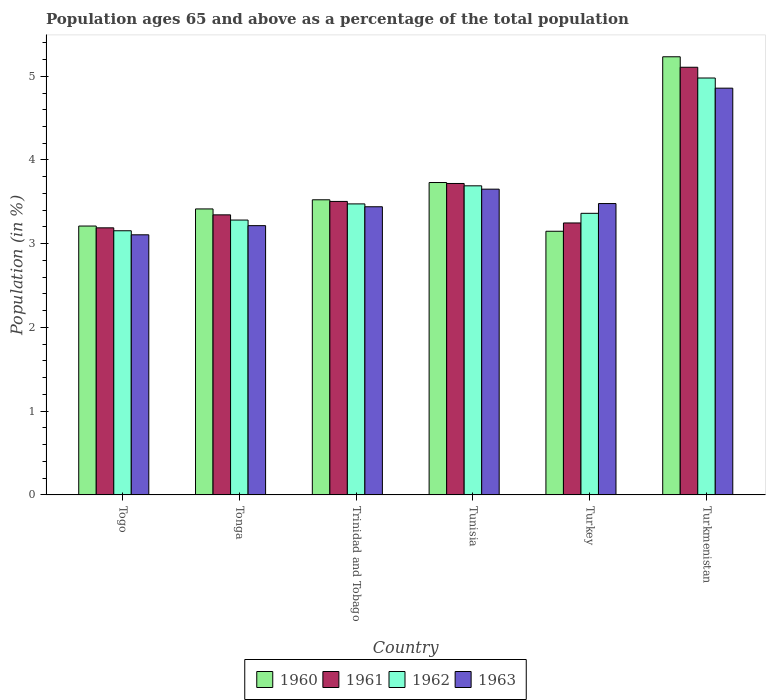How many groups of bars are there?
Your answer should be very brief. 6. Are the number of bars on each tick of the X-axis equal?
Your answer should be very brief. Yes. How many bars are there on the 6th tick from the left?
Your answer should be compact. 4. How many bars are there on the 2nd tick from the right?
Keep it short and to the point. 4. What is the label of the 3rd group of bars from the left?
Provide a succinct answer. Trinidad and Tobago. What is the percentage of the population ages 65 and above in 1963 in Turkmenistan?
Ensure brevity in your answer.  4.86. Across all countries, what is the maximum percentage of the population ages 65 and above in 1961?
Ensure brevity in your answer.  5.11. Across all countries, what is the minimum percentage of the population ages 65 and above in 1960?
Ensure brevity in your answer.  3.15. In which country was the percentage of the population ages 65 and above in 1963 maximum?
Give a very brief answer. Turkmenistan. In which country was the percentage of the population ages 65 and above in 1962 minimum?
Provide a succinct answer. Togo. What is the total percentage of the population ages 65 and above in 1962 in the graph?
Provide a succinct answer. 21.95. What is the difference between the percentage of the population ages 65 and above in 1962 in Tonga and that in Turkmenistan?
Your answer should be very brief. -1.7. What is the difference between the percentage of the population ages 65 and above in 1961 in Turkey and the percentage of the population ages 65 and above in 1960 in Tunisia?
Your answer should be compact. -0.48. What is the average percentage of the population ages 65 and above in 1962 per country?
Offer a very short reply. 3.66. What is the difference between the percentage of the population ages 65 and above of/in 1960 and percentage of the population ages 65 and above of/in 1963 in Turkmenistan?
Offer a terse response. 0.37. In how many countries, is the percentage of the population ages 65 and above in 1961 greater than 2.6?
Your answer should be very brief. 6. What is the ratio of the percentage of the population ages 65 and above in 1962 in Trinidad and Tobago to that in Turkey?
Keep it short and to the point. 1.03. Is the percentage of the population ages 65 and above in 1963 in Tunisia less than that in Turkmenistan?
Give a very brief answer. Yes. Is the difference between the percentage of the population ages 65 and above in 1960 in Togo and Tonga greater than the difference between the percentage of the population ages 65 and above in 1963 in Togo and Tonga?
Your response must be concise. No. What is the difference between the highest and the second highest percentage of the population ages 65 and above in 1960?
Your answer should be very brief. -0.21. What is the difference between the highest and the lowest percentage of the population ages 65 and above in 1960?
Your answer should be compact. 2.08. Is the sum of the percentage of the population ages 65 and above in 1963 in Tunisia and Turkmenistan greater than the maximum percentage of the population ages 65 and above in 1962 across all countries?
Provide a succinct answer. Yes. Is it the case that in every country, the sum of the percentage of the population ages 65 and above in 1963 and percentage of the population ages 65 and above in 1961 is greater than the percentage of the population ages 65 and above in 1962?
Give a very brief answer. Yes. What is the difference between two consecutive major ticks on the Y-axis?
Your answer should be very brief. 1. Are the values on the major ticks of Y-axis written in scientific E-notation?
Ensure brevity in your answer.  No. Where does the legend appear in the graph?
Make the answer very short. Bottom center. How many legend labels are there?
Offer a terse response. 4. What is the title of the graph?
Make the answer very short. Population ages 65 and above as a percentage of the total population. What is the label or title of the Y-axis?
Your response must be concise. Population (in %). What is the Population (in %) of 1960 in Togo?
Make the answer very short. 3.21. What is the Population (in %) of 1961 in Togo?
Provide a succinct answer. 3.19. What is the Population (in %) in 1962 in Togo?
Your answer should be very brief. 3.15. What is the Population (in %) of 1963 in Togo?
Make the answer very short. 3.11. What is the Population (in %) of 1960 in Tonga?
Your answer should be compact. 3.42. What is the Population (in %) in 1961 in Tonga?
Offer a very short reply. 3.34. What is the Population (in %) of 1962 in Tonga?
Ensure brevity in your answer.  3.28. What is the Population (in %) in 1963 in Tonga?
Offer a terse response. 3.22. What is the Population (in %) of 1960 in Trinidad and Tobago?
Your response must be concise. 3.52. What is the Population (in %) of 1961 in Trinidad and Tobago?
Your response must be concise. 3.51. What is the Population (in %) of 1962 in Trinidad and Tobago?
Provide a succinct answer. 3.48. What is the Population (in %) of 1963 in Trinidad and Tobago?
Your answer should be very brief. 3.44. What is the Population (in %) of 1960 in Tunisia?
Your answer should be compact. 3.73. What is the Population (in %) of 1961 in Tunisia?
Your response must be concise. 3.72. What is the Population (in %) of 1962 in Tunisia?
Provide a succinct answer. 3.69. What is the Population (in %) of 1963 in Tunisia?
Provide a short and direct response. 3.65. What is the Population (in %) in 1960 in Turkey?
Offer a terse response. 3.15. What is the Population (in %) of 1961 in Turkey?
Ensure brevity in your answer.  3.25. What is the Population (in %) in 1962 in Turkey?
Provide a succinct answer. 3.36. What is the Population (in %) of 1963 in Turkey?
Provide a succinct answer. 3.48. What is the Population (in %) of 1960 in Turkmenistan?
Offer a terse response. 5.23. What is the Population (in %) in 1961 in Turkmenistan?
Give a very brief answer. 5.11. What is the Population (in %) in 1962 in Turkmenistan?
Your answer should be very brief. 4.98. What is the Population (in %) of 1963 in Turkmenistan?
Provide a short and direct response. 4.86. Across all countries, what is the maximum Population (in %) in 1960?
Give a very brief answer. 5.23. Across all countries, what is the maximum Population (in %) of 1961?
Provide a succinct answer. 5.11. Across all countries, what is the maximum Population (in %) of 1962?
Provide a succinct answer. 4.98. Across all countries, what is the maximum Population (in %) in 1963?
Your response must be concise. 4.86. Across all countries, what is the minimum Population (in %) in 1960?
Your answer should be very brief. 3.15. Across all countries, what is the minimum Population (in %) in 1961?
Your answer should be very brief. 3.19. Across all countries, what is the minimum Population (in %) in 1962?
Offer a very short reply. 3.15. Across all countries, what is the minimum Population (in %) of 1963?
Offer a terse response. 3.11. What is the total Population (in %) of 1960 in the graph?
Keep it short and to the point. 22.26. What is the total Population (in %) in 1961 in the graph?
Provide a succinct answer. 22.11. What is the total Population (in %) of 1962 in the graph?
Your response must be concise. 21.95. What is the total Population (in %) of 1963 in the graph?
Keep it short and to the point. 21.75. What is the difference between the Population (in %) in 1960 in Togo and that in Tonga?
Offer a very short reply. -0.2. What is the difference between the Population (in %) of 1961 in Togo and that in Tonga?
Your response must be concise. -0.16. What is the difference between the Population (in %) of 1962 in Togo and that in Tonga?
Offer a terse response. -0.13. What is the difference between the Population (in %) of 1963 in Togo and that in Tonga?
Provide a short and direct response. -0.11. What is the difference between the Population (in %) in 1960 in Togo and that in Trinidad and Tobago?
Offer a terse response. -0.31. What is the difference between the Population (in %) of 1961 in Togo and that in Trinidad and Tobago?
Keep it short and to the point. -0.32. What is the difference between the Population (in %) of 1962 in Togo and that in Trinidad and Tobago?
Offer a terse response. -0.32. What is the difference between the Population (in %) in 1963 in Togo and that in Trinidad and Tobago?
Make the answer very short. -0.34. What is the difference between the Population (in %) of 1960 in Togo and that in Tunisia?
Your answer should be compact. -0.52. What is the difference between the Population (in %) of 1961 in Togo and that in Tunisia?
Keep it short and to the point. -0.53. What is the difference between the Population (in %) of 1962 in Togo and that in Tunisia?
Your response must be concise. -0.54. What is the difference between the Population (in %) of 1963 in Togo and that in Tunisia?
Keep it short and to the point. -0.55. What is the difference between the Population (in %) of 1960 in Togo and that in Turkey?
Keep it short and to the point. 0.06. What is the difference between the Population (in %) in 1961 in Togo and that in Turkey?
Make the answer very short. -0.06. What is the difference between the Population (in %) of 1962 in Togo and that in Turkey?
Provide a short and direct response. -0.21. What is the difference between the Population (in %) in 1963 in Togo and that in Turkey?
Offer a terse response. -0.37. What is the difference between the Population (in %) of 1960 in Togo and that in Turkmenistan?
Your response must be concise. -2.02. What is the difference between the Population (in %) of 1961 in Togo and that in Turkmenistan?
Offer a terse response. -1.92. What is the difference between the Population (in %) in 1962 in Togo and that in Turkmenistan?
Offer a terse response. -1.82. What is the difference between the Population (in %) in 1963 in Togo and that in Turkmenistan?
Provide a short and direct response. -1.75. What is the difference between the Population (in %) of 1960 in Tonga and that in Trinidad and Tobago?
Your response must be concise. -0.11. What is the difference between the Population (in %) in 1961 in Tonga and that in Trinidad and Tobago?
Provide a short and direct response. -0.16. What is the difference between the Population (in %) of 1962 in Tonga and that in Trinidad and Tobago?
Keep it short and to the point. -0.19. What is the difference between the Population (in %) in 1963 in Tonga and that in Trinidad and Tobago?
Provide a short and direct response. -0.23. What is the difference between the Population (in %) in 1960 in Tonga and that in Tunisia?
Give a very brief answer. -0.32. What is the difference between the Population (in %) of 1961 in Tonga and that in Tunisia?
Your answer should be very brief. -0.37. What is the difference between the Population (in %) in 1962 in Tonga and that in Tunisia?
Your answer should be very brief. -0.41. What is the difference between the Population (in %) of 1963 in Tonga and that in Tunisia?
Offer a very short reply. -0.44. What is the difference between the Population (in %) of 1960 in Tonga and that in Turkey?
Provide a succinct answer. 0.27. What is the difference between the Population (in %) in 1961 in Tonga and that in Turkey?
Provide a succinct answer. 0.1. What is the difference between the Population (in %) in 1962 in Tonga and that in Turkey?
Your response must be concise. -0.08. What is the difference between the Population (in %) in 1963 in Tonga and that in Turkey?
Provide a succinct answer. -0.26. What is the difference between the Population (in %) in 1960 in Tonga and that in Turkmenistan?
Provide a short and direct response. -1.82. What is the difference between the Population (in %) of 1961 in Tonga and that in Turkmenistan?
Your answer should be very brief. -1.76. What is the difference between the Population (in %) of 1962 in Tonga and that in Turkmenistan?
Provide a succinct answer. -1.7. What is the difference between the Population (in %) in 1963 in Tonga and that in Turkmenistan?
Keep it short and to the point. -1.64. What is the difference between the Population (in %) in 1960 in Trinidad and Tobago and that in Tunisia?
Offer a terse response. -0.21. What is the difference between the Population (in %) of 1961 in Trinidad and Tobago and that in Tunisia?
Offer a terse response. -0.21. What is the difference between the Population (in %) of 1962 in Trinidad and Tobago and that in Tunisia?
Your answer should be very brief. -0.22. What is the difference between the Population (in %) of 1963 in Trinidad and Tobago and that in Tunisia?
Provide a short and direct response. -0.21. What is the difference between the Population (in %) in 1960 in Trinidad and Tobago and that in Turkey?
Your answer should be very brief. 0.38. What is the difference between the Population (in %) in 1961 in Trinidad and Tobago and that in Turkey?
Make the answer very short. 0.26. What is the difference between the Population (in %) in 1962 in Trinidad and Tobago and that in Turkey?
Make the answer very short. 0.11. What is the difference between the Population (in %) in 1963 in Trinidad and Tobago and that in Turkey?
Offer a terse response. -0.04. What is the difference between the Population (in %) of 1960 in Trinidad and Tobago and that in Turkmenistan?
Your answer should be very brief. -1.71. What is the difference between the Population (in %) of 1961 in Trinidad and Tobago and that in Turkmenistan?
Offer a very short reply. -1.6. What is the difference between the Population (in %) in 1962 in Trinidad and Tobago and that in Turkmenistan?
Ensure brevity in your answer.  -1.5. What is the difference between the Population (in %) in 1963 in Trinidad and Tobago and that in Turkmenistan?
Provide a short and direct response. -1.42. What is the difference between the Population (in %) in 1960 in Tunisia and that in Turkey?
Provide a short and direct response. 0.58. What is the difference between the Population (in %) in 1961 in Tunisia and that in Turkey?
Your answer should be very brief. 0.47. What is the difference between the Population (in %) of 1962 in Tunisia and that in Turkey?
Your answer should be very brief. 0.33. What is the difference between the Population (in %) in 1963 in Tunisia and that in Turkey?
Keep it short and to the point. 0.17. What is the difference between the Population (in %) in 1960 in Tunisia and that in Turkmenistan?
Provide a short and direct response. -1.5. What is the difference between the Population (in %) in 1961 in Tunisia and that in Turkmenistan?
Offer a terse response. -1.39. What is the difference between the Population (in %) in 1962 in Tunisia and that in Turkmenistan?
Your response must be concise. -1.29. What is the difference between the Population (in %) of 1963 in Tunisia and that in Turkmenistan?
Your response must be concise. -1.21. What is the difference between the Population (in %) in 1960 in Turkey and that in Turkmenistan?
Give a very brief answer. -2.08. What is the difference between the Population (in %) of 1961 in Turkey and that in Turkmenistan?
Your response must be concise. -1.86. What is the difference between the Population (in %) of 1962 in Turkey and that in Turkmenistan?
Provide a short and direct response. -1.62. What is the difference between the Population (in %) in 1963 in Turkey and that in Turkmenistan?
Make the answer very short. -1.38. What is the difference between the Population (in %) in 1960 in Togo and the Population (in %) in 1961 in Tonga?
Provide a short and direct response. -0.13. What is the difference between the Population (in %) in 1960 in Togo and the Population (in %) in 1962 in Tonga?
Offer a terse response. -0.07. What is the difference between the Population (in %) in 1960 in Togo and the Population (in %) in 1963 in Tonga?
Provide a succinct answer. -0. What is the difference between the Population (in %) of 1961 in Togo and the Population (in %) of 1962 in Tonga?
Ensure brevity in your answer.  -0.09. What is the difference between the Population (in %) of 1961 in Togo and the Population (in %) of 1963 in Tonga?
Your answer should be very brief. -0.03. What is the difference between the Population (in %) of 1962 in Togo and the Population (in %) of 1963 in Tonga?
Your answer should be compact. -0.06. What is the difference between the Population (in %) in 1960 in Togo and the Population (in %) in 1961 in Trinidad and Tobago?
Provide a succinct answer. -0.29. What is the difference between the Population (in %) in 1960 in Togo and the Population (in %) in 1962 in Trinidad and Tobago?
Make the answer very short. -0.26. What is the difference between the Population (in %) in 1960 in Togo and the Population (in %) in 1963 in Trinidad and Tobago?
Your response must be concise. -0.23. What is the difference between the Population (in %) of 1961 in Togo and the Population (in %) of 1962 in Trinidad and Tobago?
Your response must be concise. -0.29. What is the difference between the Population (in %) in 1961 in Togo and the Population (in %) in 1963 in Trinidad and Tobago?
Make the answer very short. -0.25. What is the difference between the Population (in %) of 1962 in Togo and the Population (in %) of 1963 in Trinidad and Tobago?
Your response must be concise. -0.29. What is the difference between the Population (in %) in 1960 in Togo and the Population (in %) in 1961 in Tunisia?
Make the answer very short. -0.51. What is the difference between the Population (in %) in 1960 in Togo and the Population (in %) in 1962 in Tunisia?
Provide a short and direct response. -0.48. What is the difference between the Population (in %) of 1960 in Togo and the Population (in %) of 1963 in Tunisia?
Offer a terse response. -0.44. What is the difference between the Population (in %) in 1961 in Togo and the Population (in %) in 1962 in Tunisia?
Your answer should be compact. -0.5. What is the difference between the Population (in %) of 1961 in Togo and the Population (in %) of 1963 in Tunisia?
Provide a succinct answer. -0.46. What is the difference between the Population (in %) of 1962 in Togo and the Population (in %) of 1963 in Tunisia?
Your answer should be compact. -0.5. What is the difference between the Population (in %) in 1960 in Togo and the Population (in %) in 1961 in Turkey?
Offer a very short reply. -0.04. What is the difference between the Population (in %) in 1960 in Togo and the Population (in %) in 1962 in Turkey?
Your answer should be compact. -0.15. What is the difference between the Population (in %) in 1960 in Togo and the Population (in %) in 1963 in Turkey?
Your answer should be compact. -0.27. What is the difference between the Population (in %) in 1961 in Togo and the Population (in %) in 1962 in Turkey?
Your answer should be compact. -0.17. What is the difference between the Population (in %) in 1961 in Togo and the Population (in %) in 1963 in Turkey?
Give a very brief answer. -0.29. What is the difference between the Population (in %) in 1962 in Togo and the Population (in %) in 1963 in Turkey?
Provide a succinct answer. -0.32. What is the difference between the Population (in %) in 1960 in Togo and the Population (in %) in 1961 in Turkmenistan?
Ensure brevity in your answer.  -1.9. What is the difference between the Population (in %) in 1960 in Togo and the Population (in %) in 1962 in Turkmenistan?
Provide a short and direct response. -1.77. What is the difference between the Population (in %) of 1960 in Togo and the Population (in %) of 1963 in Turkmenistan?
Your response must be concise. -1.65. What is the difference between the Population (in %) in 1961 in Togo and the Population (in %) in 1962 in Turkmenistan?
Offer a very short reply. -1.79. What is the difference between the Population (in %) in 1961 in Togo and the Population (in %) in 1963 in Turkmenistan?
Offer a very short reply. -1.67. What is the difference between the Population (in %) of 1962 in Togo and the Population (in %) of 1963 in Turkmenistan?
Make the answer very short. -1.7. What is the difference between the Population (in %) in 1960 in Tonga and the Population (in %) in 1961 in Trinidad and Tobago?
Give a very brief answer. -0.09. What is the difference between the Population (in %) of 1960 in Tonga and the Population (in %) of 1962 in Trinidad and Tobago?
Make the answer very short. -0.06. What is the difference between the Population (in %) of 1960 in Tonga and the Population (in %) of 1963 in Trinidad and Tobago?
Provide a short and direct response. -0.03. What is the difference between the Population (in %) in 1961 in Tonga and the Population (in %) in 1962 in Trinidad and Tobago?
Give a very brief answer. -0.13. What is the difference between the Population (in %) in 1961 in Tonga and the Population (in %) in 1963 in Trinidad and Tobago?
Keep it short and to the point. -0.1. What is the difference between the Population (in %) of 1962 in Tonga and the Population (in %) of 1963 in Trinidad and Tobago?
Your answer should be very brief. -0.16. What is the difference between the Population (in %) of 1960 in Tonga and the Population (in %) of 1961 in Tunisia?
Ensure brevity in your answer.  -0.3. What is the difference between the Population (in %) in 1960 in Tonga and the Population (in %) in 1962 in Tunisia?
Make the answer very short. -0.28. What is the difference between the Population (in %) of 1960 in Tonga and the Population (in %) of 1963 in Tunisia?
Provide a succinct answer. -0.24. What is the difference between the Population (in %) in 1961 in Tonga and the Population (in %) in 1962 in Tunisia?
Offer a terse response. -0.35. What is the difference between the Population (in %) of 1961 in Tonga and the Population (in %) of 1963 in Tunisia?
Give a very brief answer. -0.31. What is the difference between the Population (in %) in 1962 in Tonga and the Population (in %) in 1963 in Tunisia?
Offer a very short reply. -0.37. What is the difference between the Population (in %) of 1960 in Tonga and the Population (in %) of 1961 in Turkey?
Provide a short and direct response. 0.17. What is the difference between the Population (in %) of 1960 in Tonga and the Population (in %) of 1962 in Turkey?
Make the answer very short. 0.05. What is the difference between the Population (in %) of 1960 in Tonga and the Population (in %) of 1963 in Turkey?
Provide a succinct answer. -0.06. What is the difference between the Population (in %) of 1961 in Tonga and the Population (in %) of 1962 in Turkey?
Give a very brief answer. -0.02. What is the difference between the Population (in %) in 1961 in Tonga and the Population (in %) in 1963 in Turkey?
Offer a very short reply. -0.13. What is the difference between the Population (in %) in 1962 in Tonga and the Population (in %) in 1963 in Turkey?
Make the answer very short. -0.2. What is the difference between the Population (in %) of 1960 in Tonga and the Population (in %) of 1961 in Turkmenistan?
Keep it short and to the point. -1.69. What is the difference between the Population (in %) of 1960 in Tonga and the Population (in %) of 1962 in Turkmenistan?
Make the answer very short. -1.56. What is the difference between the Population (in %) of 1960 in Tonga and the Population (in %) of 1963 in Turkmenistan?
Make the answer very short. -1.44. What is the difference between the Population (in %) of 1961 in Tonga and the Population (in %) of 1962 in Turkmenistan?
Make the answer very short. -1.63. What is the difference between the Population (in %) of 1961 in Tonga and the Population (in %) of 1963 in Turkmenistan?
Offer a very short reply. -1.51. What is the difference between the Population (in %) in 1962 in Tonga and the Population (in %) in 1963 in Turkmenistan?
Make the answer very short. -1.58. What is the difference between the Population (in %) of 1960 in Trinidad and Tobago and the Population (in %) of 1961 in Tunisia?
Your response must be concise. -0.19. What is the difference between the Population (in %) in 1960 in Trinidad and Tobago and the Population (in %) in 1962 in Tunisia?
Ensure brevity in your answer.  -0.17. What is the difference between the Population (in %) of 1960 in Trinidad and Tobago and the Population (in %) of 1963 in Tunisia?
Your answer should be very brief. -0.13. What is the difference between the Population (in %) of 1961 in Trinidad and Tobago and the Population (in %) of 1962 in Tunisia?
Provide a short and direct response. -0.19. What is the difference between the Population (in %) in 1961 in Trinidad and Tobago and the Population (in %) in 1963 in Tunisia?
Your answer should be compact. -0.15. What is the difference between the Population (in %) of 1962 in Trinidad and Tobago and the Population (in %) of 1963 in Tunisia?
Give a very brief answer. -0.18. What is the difference between the Population (in %) of 1960 in Trinidad and Tobago and the Population (in %) of 1961 in Turkey?
Your response must be concise. 0.28. What is the difference between the Population (in %) of 1960 in Trinidad and Tobago and the Population (in %) of 1962 in Turkey?
Offer a terse response. 0.16. What is the difference between the Population (in %) in 1960 in Trinidad and Tobago and the Population (in %) in 1963 in Turkey?
Offer a terse response. 0.04. What is the difference between the Population (in %) in 1961 in Trinidad and Tobago and the Population (in %) in 1962 in Turkey?
Ensure brevity in your answer.  0.14. What is the difference between the Population (in %) of 1961 in Trinidad and Tobago and the Population (in %) of 1963 in Turkey?
Keep it short and to the point. 0.03. What is the difference between the Population (in %) in 1962 in Trinidad and Tobago and the Population (in %) in 1963 in Turkey?
Your answer should be very brief. -0. What is the difference between the Population (in %) of 1960 in Trinidad and Tobago and the Population (in %) of 1961 in Turkmenistan?
Provide a short and direct response. -1.58. What is the difference between the Population (in %) of 1960 in Trinidad and Tobago and the Population (in %) of 1962 in Turkmenistan?
Offer a very short reply. -1.45. What is the difference between the Population (in %) of 1960 in Trinidad and Tobago and the Population (in %) of 1963 in Turkmenistan?
Your answer should be compact. -1.33. What is the difference between the Population (in %) of 1961 in Trinidad and Tobago and the Population (in %) of 1962 in Turkmenistan?
Your answer should be very brief. -1.47. What is the difference between the Population (in %) of 1961 in Trinidad and Tobago and the Population (in %) of 1963 in Turkmenistan?
Your response must be concise. -1.35. What is the difference between the Population (in %) of 1962 in Trinidad and Tobago and the Population (in %) of 1963 in Turkmenistan?
Make the answer very short. -1.38. What is the difference between the Population (in %) in 1960 in Tunisia and the Population (in %) in 1961 in Turkey?
Provide a succinct answer. 0.48. What is the difference between the Population (in %) in 1960 in Tunisia and the Population (in %) in 1962 in Turkey?
Give a very brief answer. 0.37. What is the difference between the Population (in %) in 1960 in Tunisia and the Population (in %) in 1963 in Turkey?
Provide a short and direct response. 0.25. What is the difference between the Population (in %) in 1961 in Tunisia and the Population (in %) in 1962 in Turkey?
Ensure brevity in your answer.  0.36. What is the difference between the Population (in %) of 1961 in Tunisia and the Population (in %) of 1963 in Turkey?
Provide a succinct answer. 0.24. What is the difference between the Population (in %) in 1962 in Tunisia and the Population (in %) in 1963 in Turkey?
Provide a succinct answer. 0.21. What is the difference between the Population (in %) in 1960 in Tunisia and the Population (in %) in 1961 in Turkmenistan?
Your response must be concise. -1.38. What is the difference between the Population (in %) of 1960 in Tunisia and the Population (in %) of 1962 in Turkmenistan?
Give a very brief answer. -1.25. What is the difference between the Population (in %) of 1960 in Tunisia and the Population (in %) of 1963 in Turkmenistan?
Give a very brief answer. -1.13. What is the difference between the Population (in %) in 1961 in Tunisia and the Population (in %) in 1962 in Turkmenistan?
Ensure brevity in your answer.  -1.26. What is the difference between the Population (in %) in 1961 in Tunisia and the Population (in %) in 1963 in Turkmenistan?
Keep it short and to the point. -1.14. What is the difference between the Population (in %) in 1962 in Tunisia and the Population (in %) in 1963 in Turkmenistan?
Provide a short and direct response. -1.17. What is the difference between the Population (in %) in 1960 in Turkey and the Population (in %) in 1961 in Turkmenistan?
Keep it short and to the point. -1.96. What is the difference between the Population (in %) of 1960 in Turkey and the Population (in %) of 1962 in Turkmenistan?
Offer a very short reply. -1.83. What is the difference between the Population (in %) in 1960 in Turkey and the Population (in %) in 1963 in Turkmenistan?
Give a very brief answer. -1.71. What is the difference between the Population (in %) of 1961 in Turkey and the Population (in %) of 1962 in Turkmenistan?
Offer a terse response. -1.73. What is the difference between the Population (in %) in 1961 in Turkey and the Population (in %) in 1963 in Turkmenistan?
Keep it short and to the point. -1.61. What is the difference between the Population (in %) of 1962 in Turkey and the Population (in %) of 1963 in Turkmenistan?
Offer a terse response. -1.49. What is the average Population (in %) of 1960 per country?
Provide a succinct answer. 3.71. What is the average Population (in %) in 1961 per country?
Your answer should be compact. 3.69. What is the average Population (in %) of 1962 per country?
Offer a terse response. 3.66. What is the average Population (in %) of 1963 per country?
Make the answer very short. 3.63. What is the difference between the Population (in %) in 1960 and Population (in %) in 1961 in Togo?
Keep it short and to the point. 0.02. What is the difference between the Population (in %) in 1960 and Population (in %) in 1962 in Togo?
Provide a succinct answer. 0.06. What is the difference between the Population (in %) in 1960 and Population (in %) in 1963 in Togo?
Ensure brevity in your answer.  0.1. What is the difference between the Population (in %) of 1961 and Population (in %) of 1962 in Togo?
Give a very brief answer. 0.04. What is the difference between the Population (in %) in 1961 and Population (in %) in 1963 in Togo?
Your answer should be very brief. 0.08. What is the difference between the Population (in %) in 1962 and Population (in %) in 1963 in Togo?
Give a very brief answer. 0.05. What is the difference between the Population (in %) in 1960 and Population (in %) in 1961 in Tonga?
Your answer should be compact. 0.07. What is the difference between the Population (in %) of 1960 and Population (in %) of 1962 in Tonga?
Your answer should be compact. 0.13. What is the difference between the Population (in %) of 1960 and Population (in %) of 1963 in Tonga?
Offer a terse response. 0.2. What is the difference between the Population (in %) of 1961 and Population (in %) of 1962 in Tonga?
Make the answer very short. 0.06. What is the difference between the Population (in %) of 1961 and Population (in %) of 1963 in Tonga?
Offer a very short reply. 0.13. What is the difference between the Population (in %) in 1962 and Population (in %) in 1963 in Tonga?
Offer a terse response. 0.07. What is the difference between the Population (in %) of 1960 and Population (in %) of 1961 in Trinidad and Tobago?
Provide a succinct answer. 0.02. What is the difference between the Population (in %) of 1960 and Population (in %) of 1962 in Trinidad and Tobago?
Your answer should be compact. 0.05. What is the difference between the Population (in %) in 1960 and Population (in %) in 1963 in Trinidad and Tobago?
Ensure brevity in your answer.  0.08. What is the difference between the Population (in %) of 1961 and Population (in %) of 1962 in Trinidad and Tobago?
Your answer should be very brief. 0.03. What is the difference between the Population (in %) of 1961 and Population (in %) of 1963 in Trinidad and Tobago?
Make the answer very short. 0.06. What is the difference between the Population (in %) in 1962 and Population (in %) in 1963 in Trinidad and Tobago?
Offer a terse response. 0.03. What is the difference between the Population (in %) of 1960 and Population (in %) of 1961 in Tunisia?
Offer a terse response. 0.01. What is the difference between the Population (in %) in 1960 and Population (in %) in 1962 in Tunisia?
Provide a short and direct response. 0.04. What is the difference between the Population (in %) of 1960 and Population (in %) of 1963 in Tunisia?
Offer a very short reply. 0.08. What is the difference between the Population (in %) in 1961 and Population (in %) in 1962 in Tunisia?
Ensure brevity in your answer.  0.03. What is the difference between the Population (in %) of 1961 and Population (in %) of 1963 in Tunisia?
Offer a terse response. 0.07. What is the difference between the Population (in %) in 1962 and Population (in %) in 1963 in Tunisia?
Your answer should be very brief. 0.04. What is the difference between the Population (in %) of 1960 and Population (in %) of 1961 in Turkey?
Make the answer very short. -0.1. What is the difference between the Population (in %) of 1960 and Population (in %) of 1962 in Turkey?
Offer a very short reply. -0.21. What is the difference between the Population (in %) in 1960 and Population (in %) in 1963 in Turkey?
Give a very brief answer. -0.33. What is the difference between the Population (in %) of 1961 and Population (in %) of 1962 in Turkey?
Provide a short and direct response. -0.12. What is the difference between the Population (in %) in 1961 and Population (in %) in 1963 in Turkey?
Give a very brief answer. -0.23. What is the difference between the Population (in %) of 1962 and Population (in %) of 1963 in Turkey?
Provide a short and direct response. -0.12. What is the difference between the Population (in %) of 1960 and Population (in %) of 1961 in Turkmenistan?
Keep it short and to the point. 0.13. What is the difference between the Population (in %) in 1960 and Population (in %) in 1962 in Turkmenistan?
Keep it short and to the point. 0.25. What is the difference between the Population (in %) in 1960 and Population (in %) in 1963 in Turkmenistan?
Offer a very short reply. 0.37. What is the difference between the Population (in %) in 1961 and Population (in %) in 1962 in Turkmenistan?
Offer a very short reply. 0.13. What is the difference between the Population (in %) of 1961 and Population (in %) of 1963 in Turkmenistan?
Make the answer very short. 0.25. What is the difference between the Population (in %) of 1962 and Population (in %) of 1963 in Turkmenistan?
Your answer should be very brief. 0.12. What is the ratio of the Population (in %) in 1960 in Togo to that in Tonga?
Make the answer very short. 0.94. What is the ratio of the Population (in %) in 1961 in Togo to that in Tonga?
Offer a terse response. 0.95. What is the ratio of the Population (in %) of 1960 in Togo to that in Trinidad and Tobago?
Your answer should be compact. 0.91. What is the ratio of the Population (in %) of 1961 in Togo to that in Trinidad and Tobago?
Offer a terse response. 0.91. What is the ratio of the Population (in %) of 1962 in Togo to that in Trinidad and Tobago?
Ensure brevity in your answer.  0.91. What is the ratio of the Population (in %) in 1963 in Togo to that in Trinidad and Tobago?
Your response must be concise. 0.9. What is the ratio of the Population (in %) of 1960 in Togo to that in Tunisia?
Your response must be concise. 0.86. What is the ratio of the Population (in %) of 1961 in Togo to that in Tunisia?
Provide a short and direct response. 0.86. What is the ratio of the Population (in %) in 1962 in Togo to that in Tunisia?
Offer a terse response. 0.85. What is the ratio of the Population (in %) of 1963 in Togo to that in Tunisia?
Your answer should be very brief. 0.85. What is the ratio of the Population (in %) in 1960 in Togo to that in Turkey?
Offer a terse response. 1.02. What is the ratio of the Population (in %) in 1961 in Togo to that in Turkey?
Give a very brief answer. 0.98. What is the ratio of the Population (in %) of 1962 in Togo to that in Turkey?
Give a very brief answer. 0.94. What is the ratio of the Population (in %) of 1963 in Togo to that in Turkey?
Keep it short and to the point. 0.89. What is the ratio of the Population (in %) of 1960 in Togo to that in Turkmenistan?
Give a very brief answer. 0.61. What is the ratio of the Population (in %) of 1961 in Togo to that in Turkmenistan?
Give a very brief answer. 0.62. What is the ratio of the Population (in %) of 1962 in Togo to that in Turkmenistan?
Give a very brief answer. 0.63. What is the ratio of the Population (in %) of 1963 in Togo to that in Turkmenistan?
Your answer should be very brief. 0.64. What is the ratio of the Population (in %) in 1960 in Tonga to that in Trinidad and Tobago?
Your response must be concise. 0.97. What is the ratio of the Population (in %) in 1961 in Tonga to that in Trinidad and Tobago?
Your answer should be very brief. 0.95. What is the ratio of the Population (in %) of 1962 in Tonga to that in Trinidad and Tobago?
Your answer should be very brief. 0.94. What is the ratio of the Population (in %) in 1963 in Tonga to that in Trinidad and Tobago?
Offer a terse response. 0.93. What is the ratio of the Population (in %) of 1960 in Tonga to that in Tunisia?
Provide a succinct answer. 0.92. What is the ratio of the Population (in %) of 1961 in Tonga to that in Tunisia?
Make the answer very short. 0.9. What is the ratio of the Population (in %) of 1962 in Tonga to that in Tunisia?
Make the answer very short. 0.89. What is the ratio of the Population (in %) of 1963 in Tonga to that in Tunisia?
Provide a short and direct response. 0.88. What is the ratio of the Population (in %) in 1960 in Tonga to that in Turkey?
Offer a terse response. 1.08. What is the ratio of the Population (in %) of 1961 in Tonga to that in Turkey?
Your answer should be compact. 1.03. What is the ratio of the Population (in %) in 1962 in Tonga to that in Turkey?
Your answer should be very brief. 0.98. What is the ratio of the Population (in %) in 1963 in Tonga to that in Turkey?
Offer a very short reply. 0.92. What is the ratio of the Population (in %) of 1960 in Tonga to that in Turkmenistan?
Offer a terse response. 0.65. What is the ratio of the Population (in %) of 1961 in Tonga to that in Turkmenistan?
Your response must be concise. 0.65. What is the ratio of the Population (in %) in 1962 in Tonga to that in Turkmenistan?
Provide a succinct answer. 0.66. What is the ratio of the Population (in %) of 1963 in Tonga to that in Turkmenistan?
Make the answer very short. 0.66. What is the ratio of the Population (in %) in 1960 in Trinidad and Tobago to that in Tunisia?
Offer a very short reply. 0.94. What is the ratio of the Population (in %) of 1961 in Trinidad and Tobago to that in Tunisia?
Provide a short and direct response. 0.94. What is the ratio of the Population (in %) of 1962 in Trinidad and Tobago to that in Tunisia?
Ensure brevity in your answer.  0.94. What is the ratio of the Population (in %) of 1963 in Trinidad and Tobago to that in Tunisia?
Provide a short and direct response. 0.94. What is the ratio of the Population (in %) of 1960 in Trinidad and Tobago to that in Turkey?
Provide a succinct answer. 1.12. What is the ratio of the Population (in %) of 1961 in Trinidad and Tobago to that in Turkey?
Provide a short and direct response. 1.08. What is the ratio of the Population (in %) of 1962 in Trinidad and Tobago to that in Turkey?
Provide a succinct answer. 1.03. What is the ratio of the Population (in %) of 1960 in Trinidad and Tobago to that in Turkmenistan?
Your answer should be compact. 0.67. What is the ratio of the Population (in %) of 1961 in Trinidad and Tobago to that in Turkmenistan?
Provide a short and direct response. 0.69. What is the ratio of the Population (in %) of 1962 in Trinidad and Tobago to that in Turkmenistan?
Give a very brief answer. 0.7. What is the ratio of the Population (in %) in 1963 in Trinidad and Tobago to that in Turkmenistan?
Provide a short and direct response. 0.71. What is the ratio of the Population (in %) of 1960 in Tunisia to that in Turkey?
Offer a very short reply. 1.18. What is the ratio of the Population (in %) of 1961 in Tunisia to that in Turkey?
Provide a short and direct response. 1.15. What is the ratio of the Population (in %) of 1962 in Tunisia to that in Turkey?
Give a very brief answer. 1.1. What is the ratio of the Population (in %) in 1963 in Tunisia to that in Turkey?
Provide a short and direct response. 1.05. What is the ratio of the Population (in %) of 1960 in Tunisia to that in Turkmenistan?
Offer a terse response. 0.71. What is the ratio of the Population (in %) in 1961 in Tunisia to that in Turkmenistan?
Offer a very short reply. 0.73. What is the ratio of the Population (in %) of 1962 in Tunisia to that in Turkmenistan?
Offer a terse response. 0.74. What is the ratio of the Population (in %) in 1963 in Tunisia to that in Turkmenistan?
Provide a short and direct response. 0.75. What is the ratio of the Population (in %) in 1960 in Turkey to that in Turkmenistan?
Your answer should be compact. 0.6. What is the ratio of the Population (in %) in 1961 in Turkey to that in Turkmenistan?
Offer a terse response. 0.64. What is the ratio of the Population (in %) in 1962 in Turkey to that in Turkmenistan?
Offer a terse response. 0.68. What is the ratio of the Population (in %) of 1963 in Turkey to that in Turkmenistan?
Your answer should be compact. 0.72. What is the difference between the highest and the second highest Population (in %) of 1960?
Give a very brief answer. 1.5. What is the difference between the highest and the second highest Population (in %) of 1961?
Give a very brief answer. 1.39. What is the difference between the highest and the second highest Population (in %) of 1962?
Keep it short and to the point. 1.29. What is the difference between the highest and the second highest Population (in %) of 1963?
Provide a short and direct response. 1.21. What is the difference between the highest and the lowest Population (in %) in 1960?
Your answer should be very brief. 2.08. What is the difference between the highest and the lowest Population (in %) in 1961?
Offer a very short reply. 1.92. What is the difference between the highest and the lowest Population (in %) in 1962?
Your answer should be very brief. 1.82. What is the difference between the highest and the lowest Population (in %) of 1963?
Your answer should be compact. 1.75. 